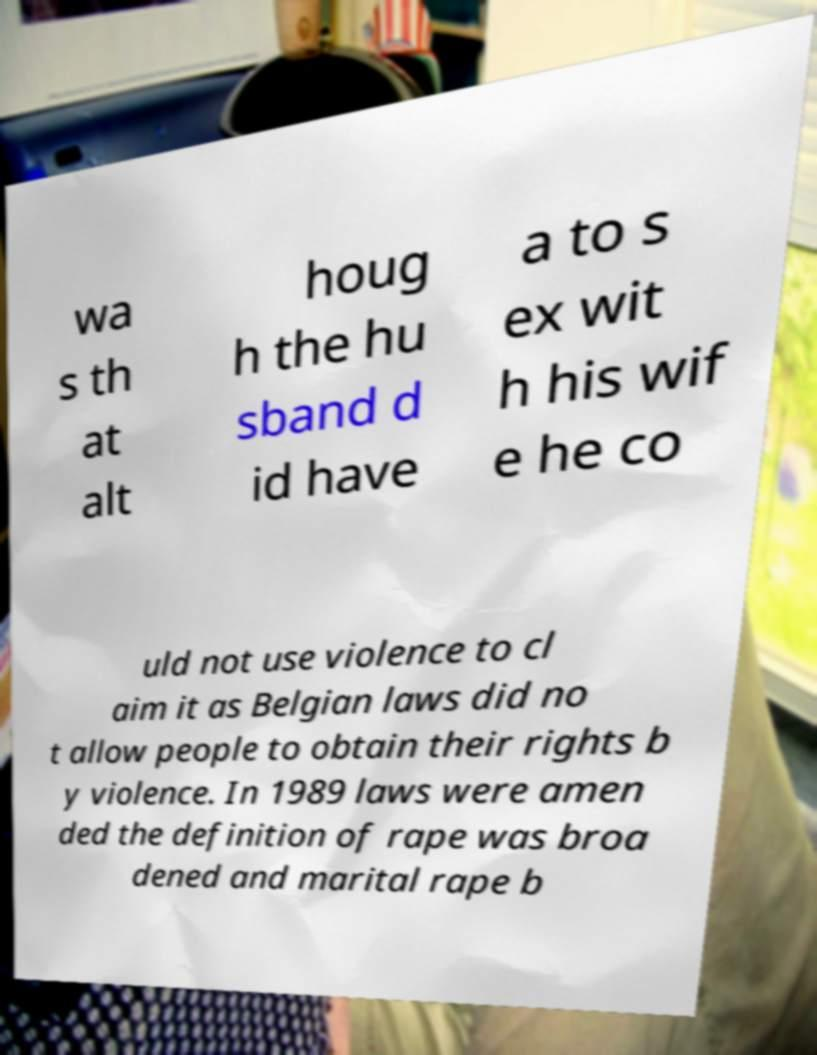Can you read and provide the text displayed in the image?This photo seems to have some interesting text. Can you extract and type it out for me? wa s th at alt houg h the hu sband d id have a to s ex wit h his wif e he co uld not use violence to cl aim it as Belgian laws did no t allow people to obtain their rights b y violence. In 1989 laws were amen ded the definition of rape was broa dened and marital rape b 